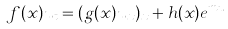Convert formula to latex. <formula><loc_0><loc_0><loc_500><loc_500>f ( x ) u _ { t } = ( g ( x ) u _ { x } ) _ { x } + h ( x ) e ^ { m u }</formula> 